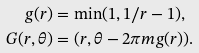Convert formula to latex. <formula><loc_0><loc_0><loc_500><loc_500>g ( r ) & = \min ( 1 , 1 / r - 1 ) , \\ G ( r , \theta ) & = ( r , \theta - 2 \pi m g ( r ) ) .</formula> 